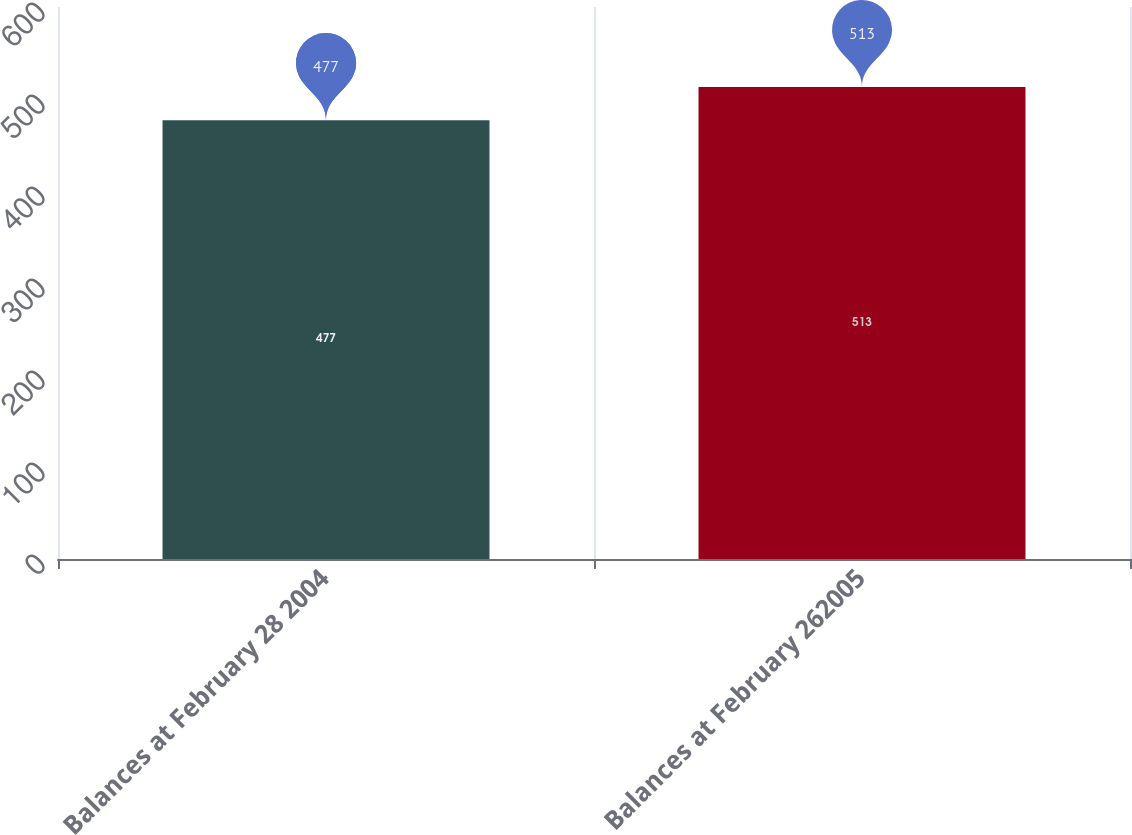Convert chart to OTSL. <chart><loc_0><loc_0><loc_500><loc_500><bar_chart><fcel>Balances at February 28 2004<fcel>Balances at February 262005<nl><fcel>477<fcel>513<nl></chart> 